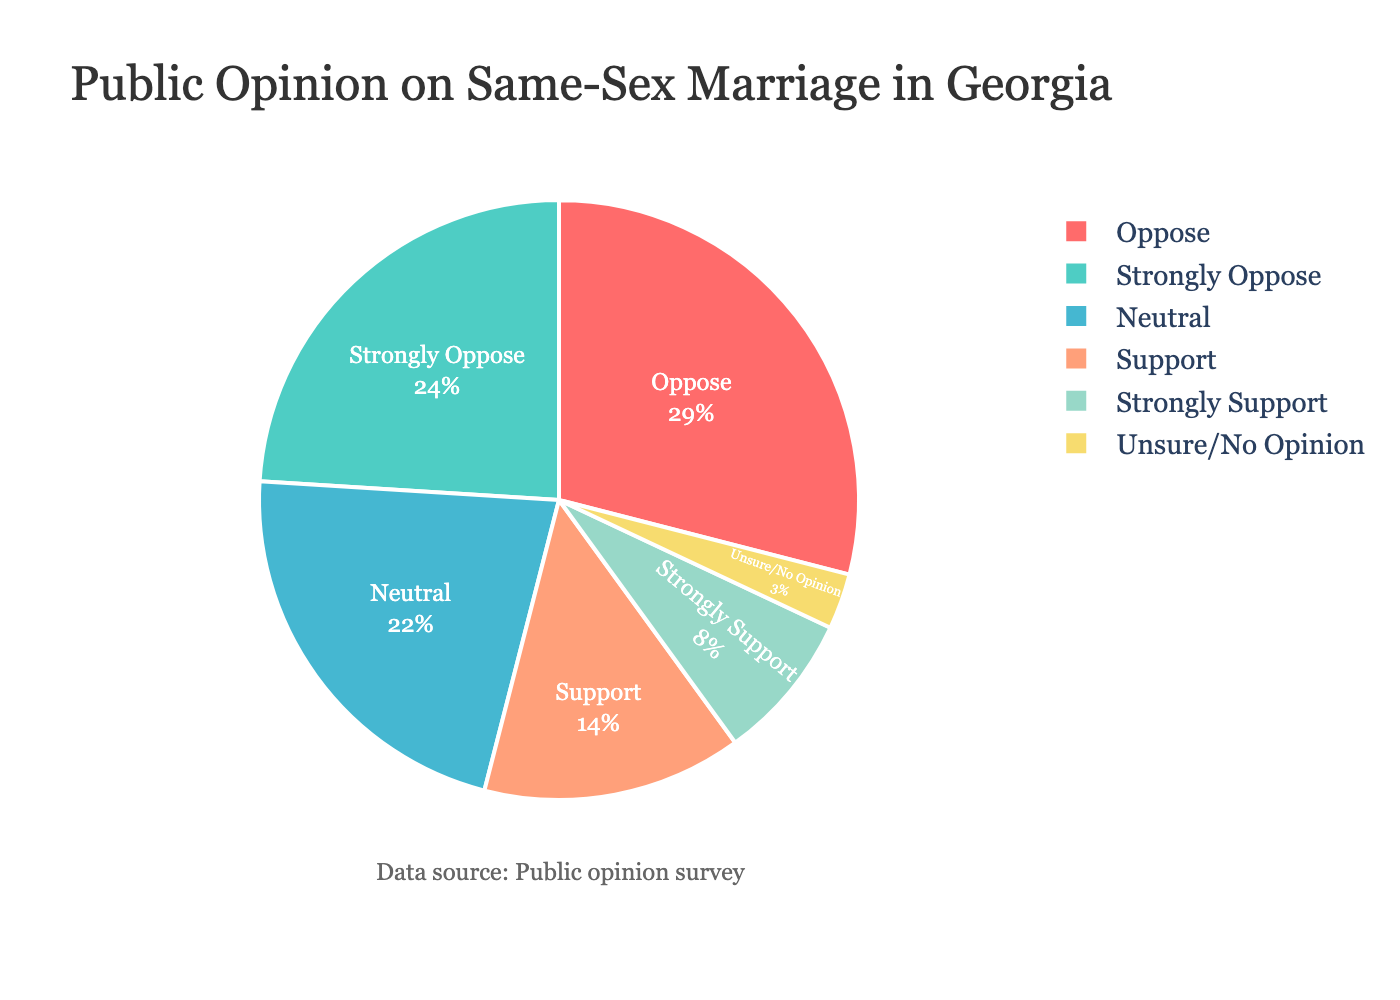What percentage of people support same-sex marriage (adding together 'Strongly Support' and 'Support')? To find the total percentage of people who support same-sex marriage, we sum the percentages of 'Strongly Support' and 'Support'. This calculation is 8% + 14% = 22%.
Answer: 22% What is the percentage difference between those who 'Neutral' and those who 'Oppose'? We need to subtract the percentage of people who are 'Neutral' from the percentage of people who 'Oppose'. This is 29% - 22% = 7%.
Answer: 7% Which category has the smallest percentage of respondents? To determine the smallest category, we compare the percentages of each category. 'Unsure/No Opinion' has the smallest percentage at 3%.
Answer: Unsure/No Opinion How does the percentage of 'Strongly Oppose' compare to 'Support'? We compare the two percentages directly, noting that 24% ('Strongly Oppose') is greater than 14% ('Support').
Answer: 24% vs 14% What combined percentage of people are either 'Neutral' or 'Unsure/No Opinion'? We add the percentages of 'Neutral' and 'Unsure/No Opinion'. This is 22% + 3% = 25%.
Answer: 25% What is the difference in percentage points between the top two categories? The top two categories are 'Oppose' and 'Strongly Oppose'. The difference is calculated as 29% - 24% = 5%.
Answer: 5% What color represents the 'Strongly Support' category? The 'Strongly Support' category is represented by the first color in the legend, which is red.
Answer: Red Which category has the second highest percentage? By examining the percentages, 'Strongly Oppose' with 24% has the second highest percentage after 'Oppose'.
Answer: Strongly Oppose If we group 'Support' and 'Neutral' categories together, what percentage do they represent in total? By summing the percentages of 'Support' (14%) and 'Neutral' (22%), we get 14% + 22% = 36%.
Answer: 36% What is the total percentage of respondents that either 'Oppose' or 'Strongly Oppose' same-sex marriage? We sum the percentages of 'Oppose' (29%) and 'Strongly Oppose' (24%). This results in 29% + 24% = 53%.
Answer: 53% 